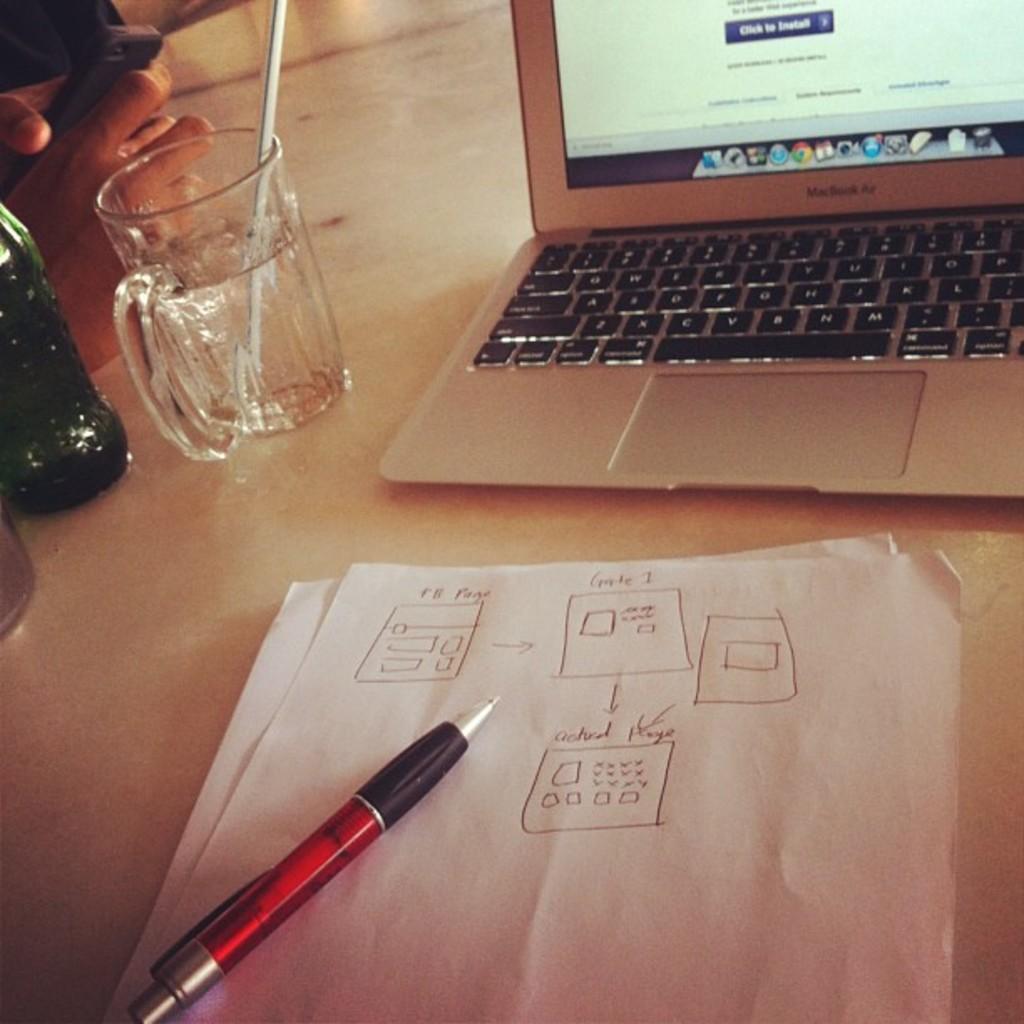Describe this image in one or two sentences. In this image there are papers, pen, a person's fingers, laptop, glass, bottle, mobile and straw are on the white platform.   